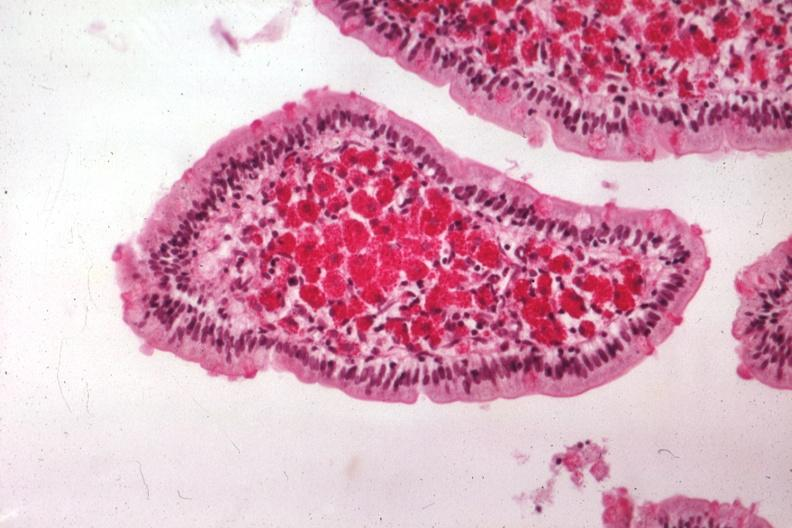s intraductal papillomatosis present?
Answer the question using a single word or phrase. No 